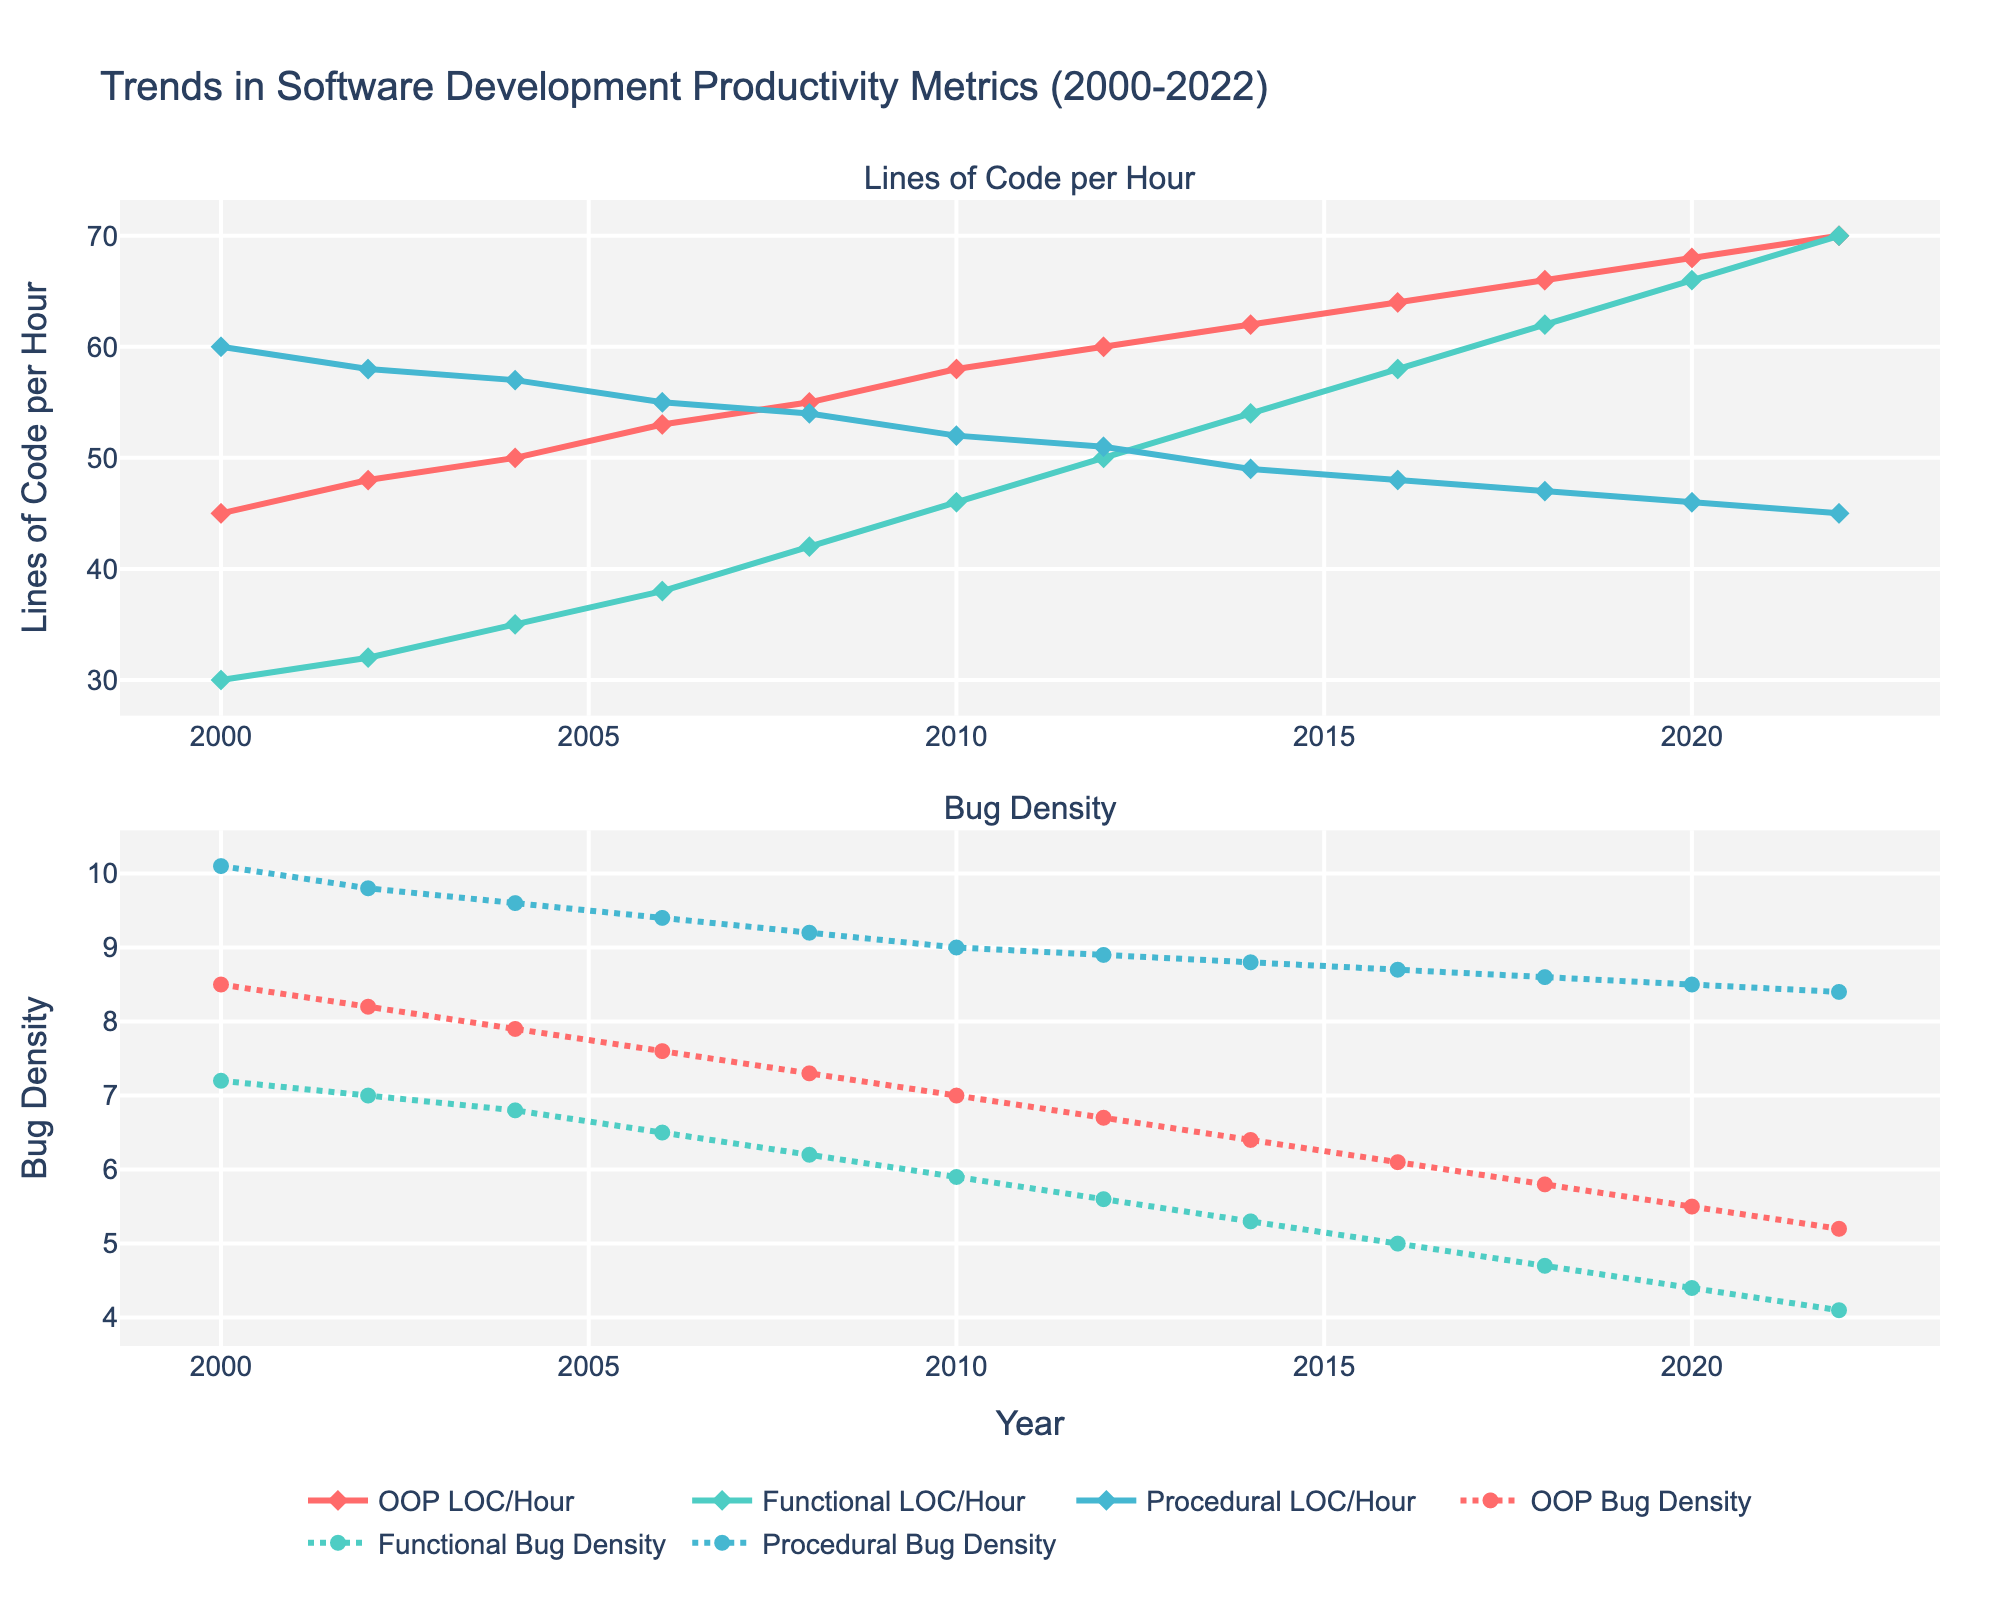Which paradigm had the highest Lines of Code per Hour (LOC) in 2022? The highest value in the chart for 2022 in the "Lines of Code per Hour" subplot corresponds to one of the paradigm lines. The colored line for OOP reaches 70 LOC per hour in 2022, which is the highest.
Answer: OOP How did the bug density of Functional paradigm change from 2014 to 2022? To find the change, look at the "Bug Density" subplot and compare the bug density value for Functional in 2014 and 2022. In 2014, Functional had a bug density of 5.3, and in 2022 it is 4.1. The change is 5.3 - 4.1.
Answer: -1.2 What is the average Lines of Code per Hour (LOC) for Procedural paradigm over the entire period? Sum the values of Procedural LOC per Hour provided in the figure and divide by the number of years. The values are: 60, 58, 57, 55, 54, 52, 51, 49, 48, 47, 46, 45. Summing these gives 622, and dividing by 12 gives 51.83.
Answer: 51.83 Which programming paradigm shows a decreasing trend in bug density the fastest? Look at the slopes of the lines in the "Bug Density" subplot. The steepest decline is represented by the Functional paradigm line, which drops from 7.2 in 2000 to 4.1 in 2022.
Answer: Functional What is the difference in Lines of Code per Hour (LOC) between OOP and Procedural paradigms in 2018? Compare the "Lines of Code per Hour" values for OOP and Procedural in 2018. For OOP, it is 66 and for Procedural, it is 47. The difference is 66 - 47.
Answer: 19 Which year did Functional paradigm surpass OOP in Lines of Code per Hour (LOC)? Look at the intersection in the "Lines of Code per Hour" subplot. The two lines intersect at the year 2022, where both paradigms have 70 LOC.
Answer: 2022 How much has the Bug Density of OOP decreased from 2000 to 2022? Examine the "Bug Density" values for OOP in 2000 and 2022. In 2000, OOP had a Bug Density of 8.5, and in 2022 it is 5.2. The decrease is 8.5 - 5.2.
Answer: 3.3 In which year did the Functional paradigm's Lines of Code per Hour (LOC) first exceed 50? Find the first year in which the Functional paradigm's LOC per Hour exceeds 50 in the subplot. The year when the value first exceeds 50 is 2012.
Answer: 2012 